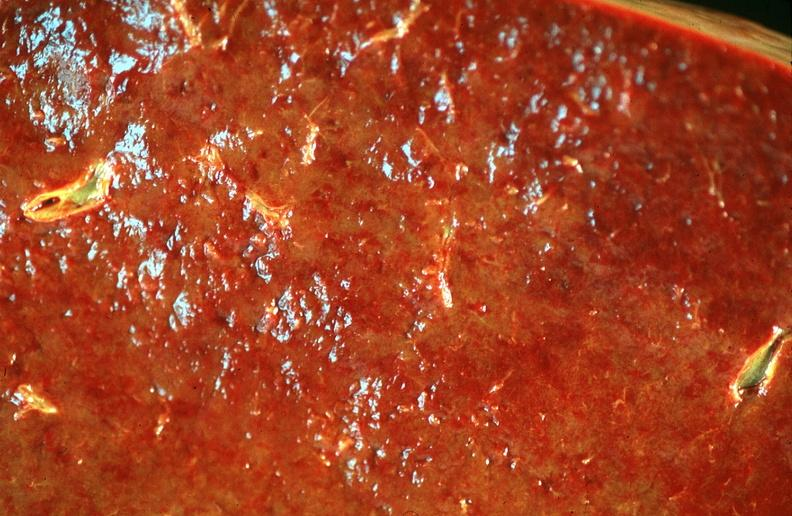what does this image show?
Answer the question using a single word or phrase. Spleen 